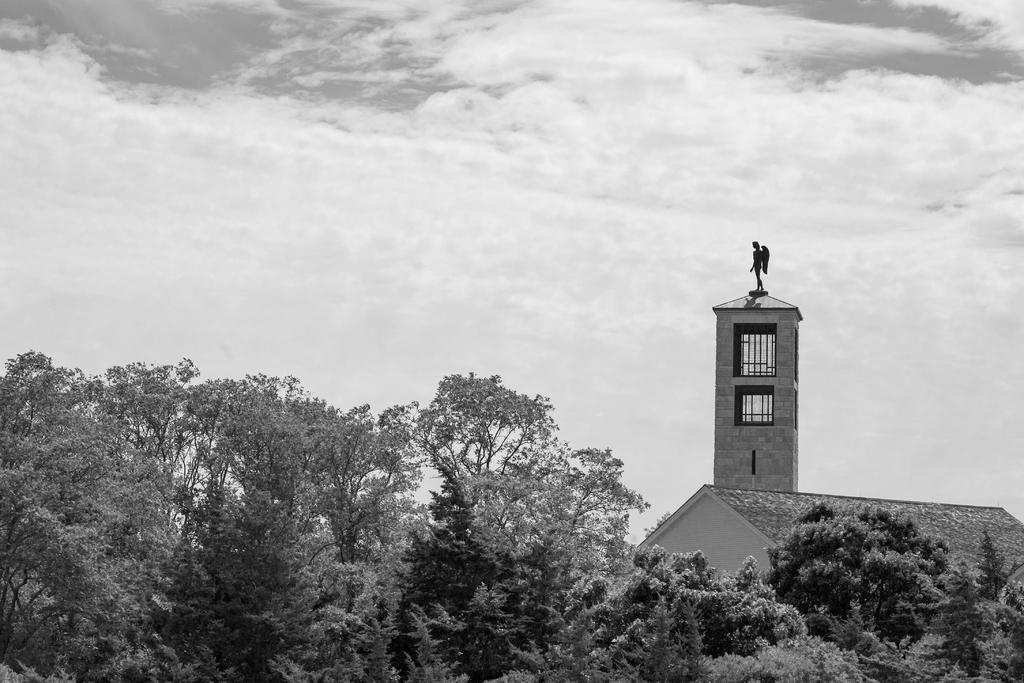What type of vegetation is visible in front of the image? There are trees in front of the image. What type of structure is present in the image? There is a building in the image. What is on top of the building? There is a statue on top of the building. What is visible at the top of the image? The sky is visible at the top of the image. What type of honey is being served on the tray in the image? There is no tray or honey present in the image. What holiday is being celebrated in the image? There is no indication of a holiday being celebrated in the image. 